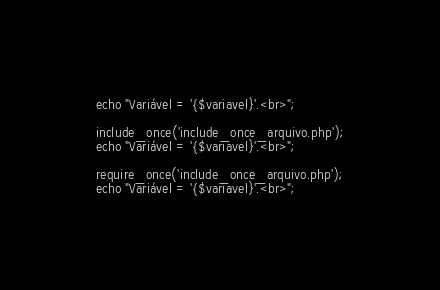<code> <loc_0><loc_0><loc_500><loc_500><_PHP_>echo "Variável = '{$variavel}'.<br>";

include_once('include_once_arquivo.php');
echo "Variável = '{$variavel}'.<br>";

require_once('include_once_arquivo.php');
echo "Variável = '{$variavel}'.<br>";</code> 